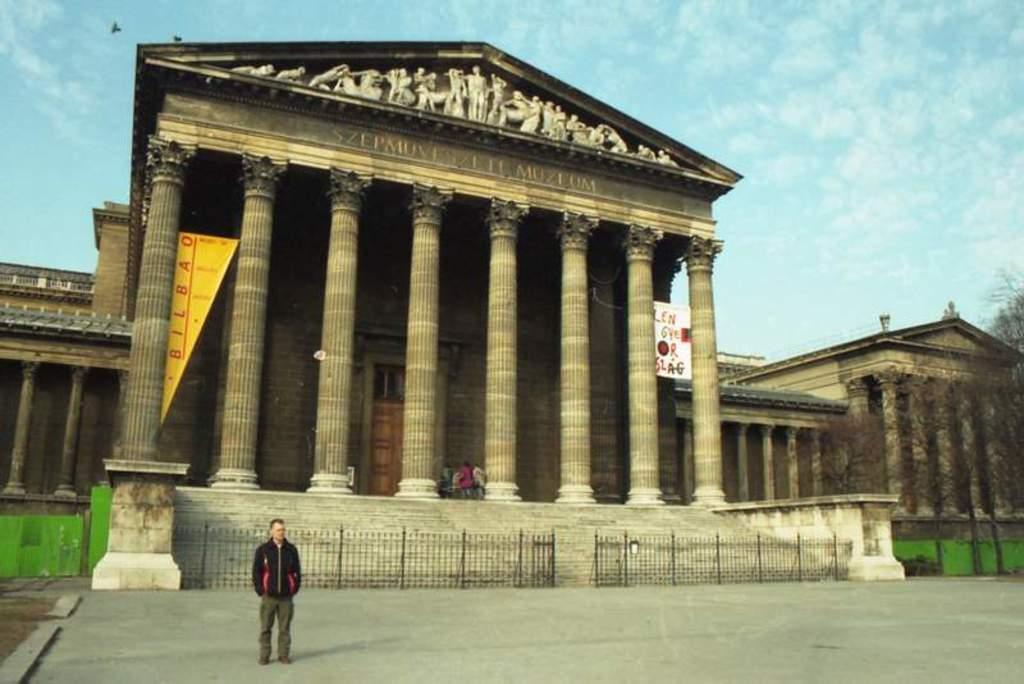Could you give a brief overview of what you see in this image? In this image I can see few buildings, pillars, trees, banners, fencing, sky and one person is standing. 